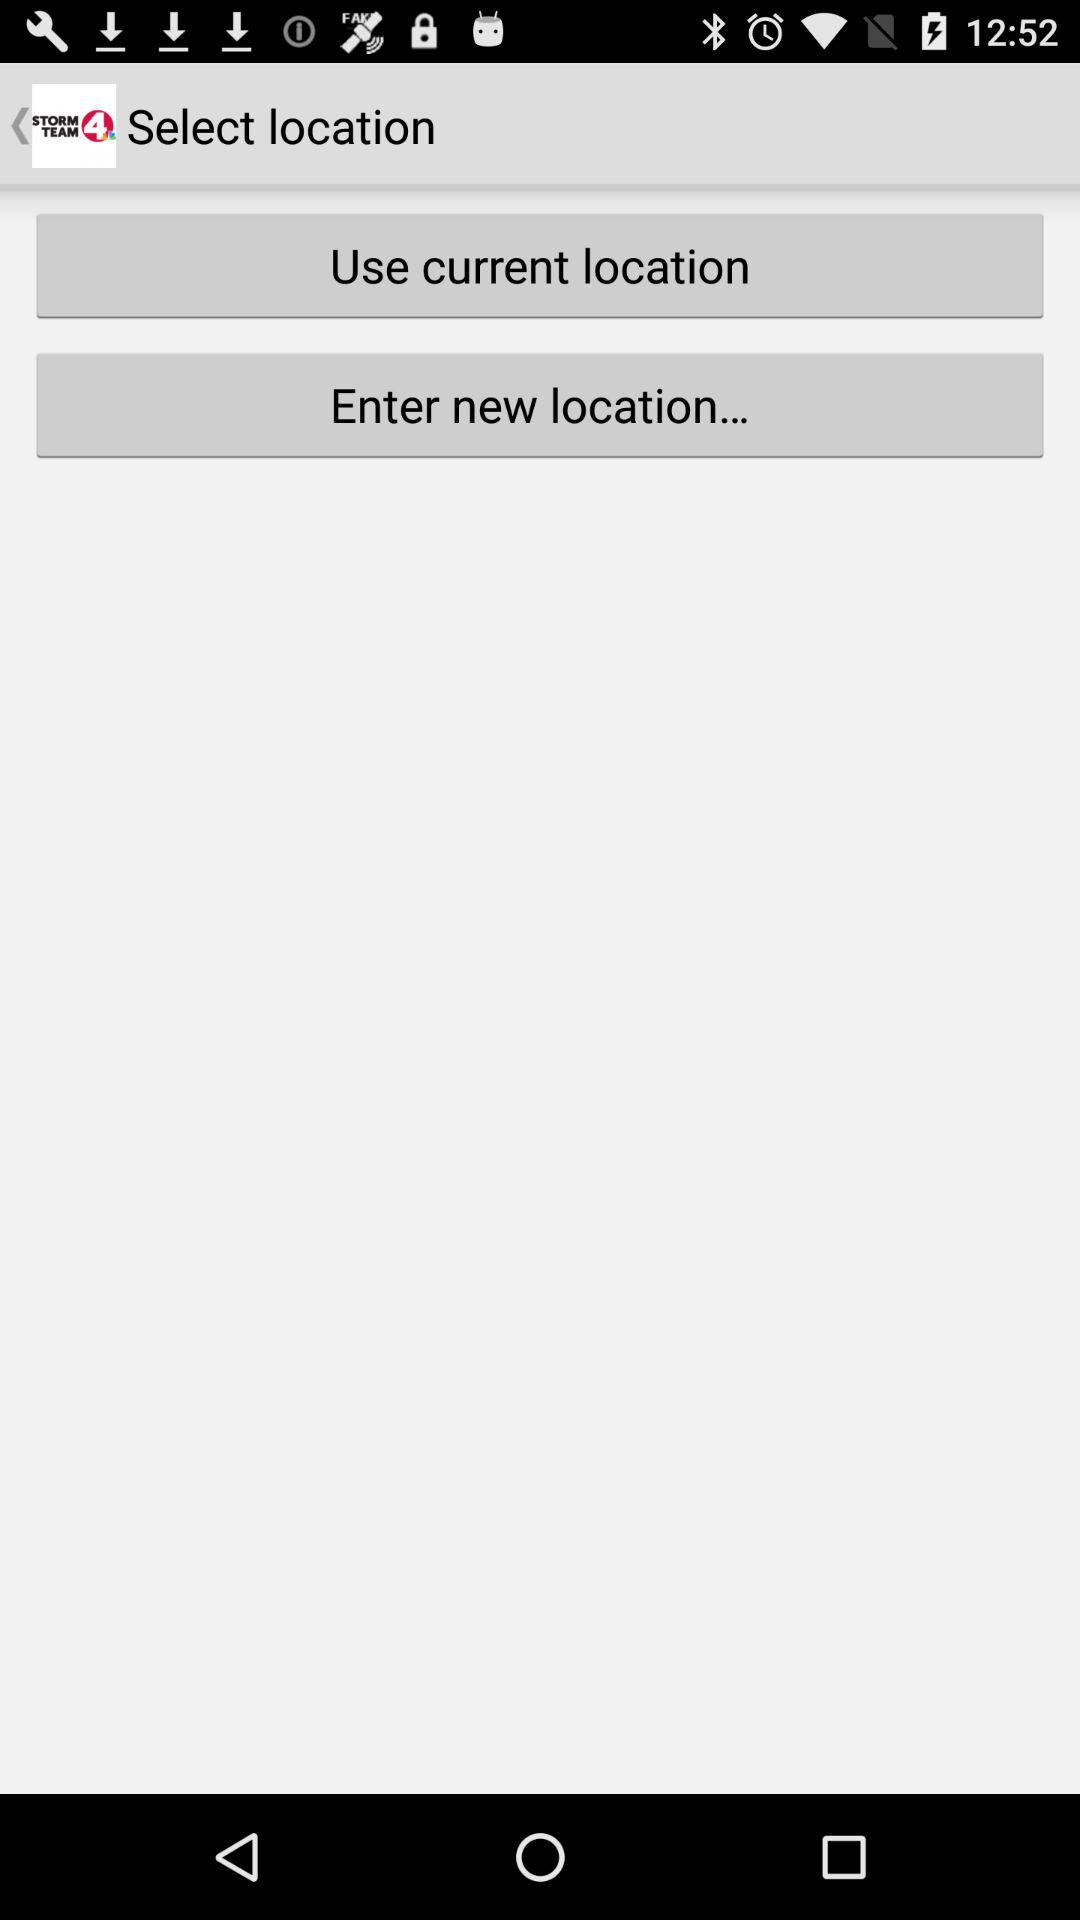What is the application name? The application name is "STORM TEAM 4". 